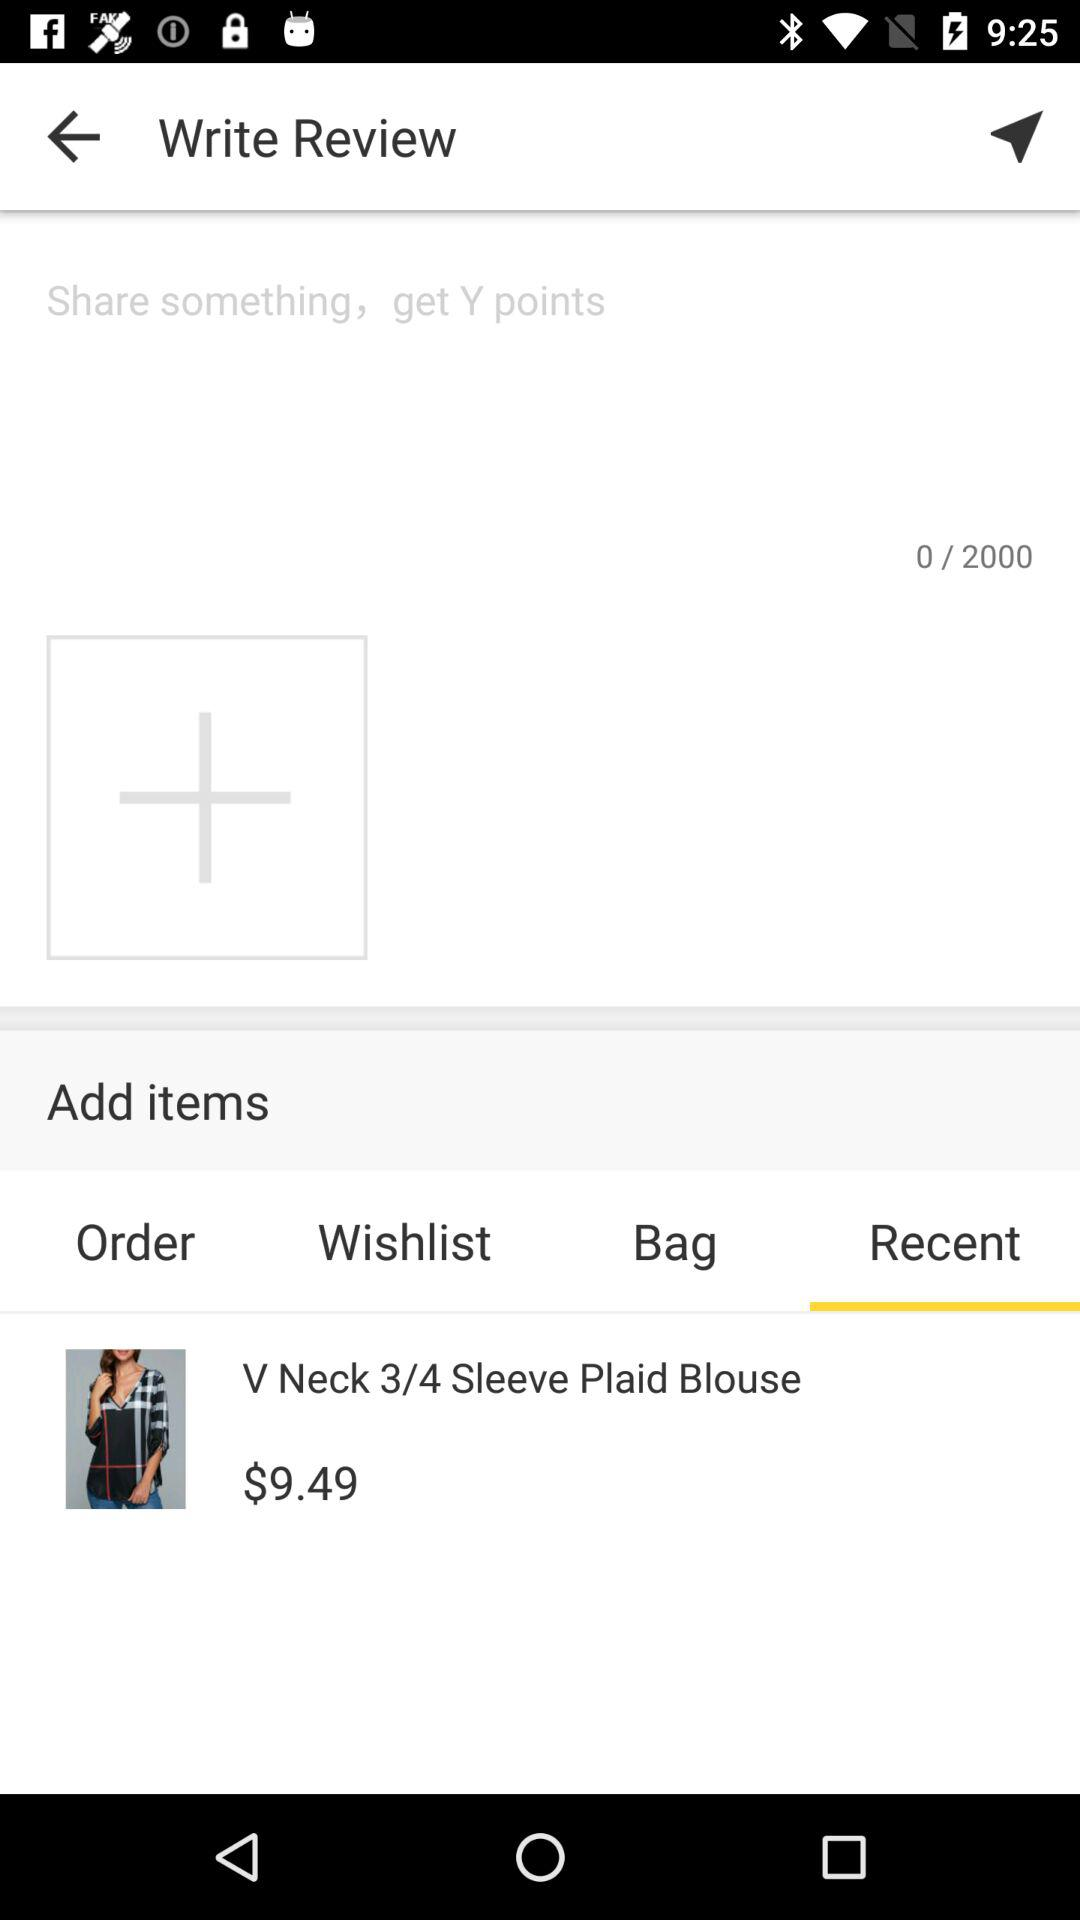What is the price of the "V Neck 3/4 Sleeve Plaid Blouse"? The price is $9.49. 